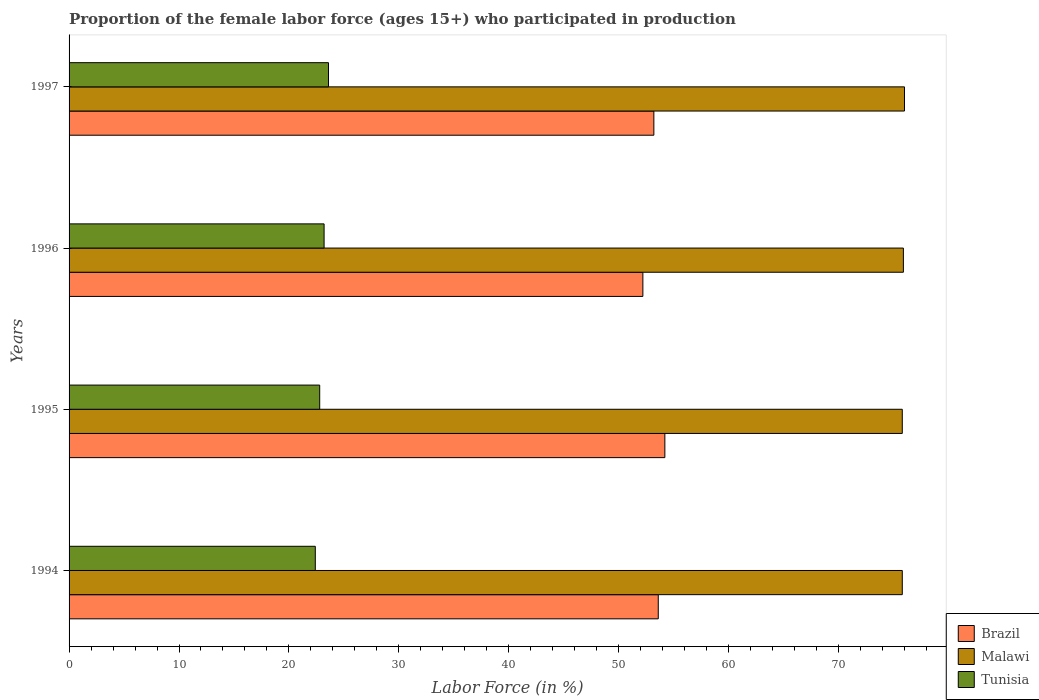How many different coloured bars are there?
Your answer should be compact. 3. How many groups of bars are there?
Provide a succinct answer. 4. Are the number of bars per tick equal to the number of legend labels?
Your response must be concise. Yes. What is the label of the 3rd group of bars from the top?
Your response must be concise. 1995. What is the proportion of the female labor force who participated in production in Brazil in 1997?
Offer a very short reply. 53.2. Across all years, what is the maximum proportion of the female labor force who participated in production in Tunisia?
Ensure brevity in your answer.  23.6. Across all years, what is the minimum proportion of the female labor force who participated in production in Brazil?
Your answer should be very brief. 52.2. In which year was the proportion of the female labor force who participated in production in Tunisia maximum?
Offer a very short reply. 1997. What is the total proportion of the female labor force who participated in production in Tunisia in the graph?
Your answer should be compact. 92. What is the difference between the proportion of the female labor force who participated in production in Tunisia in 1995 and that in 1996?
Ensure brevity in your answer.  -0.4. What is the difference between the proportion of the female labor force who participated in production in Tunisia in 1996 and the proportion of the female labor force who participated in production in Brazil in 1995?
Give a very brief answer. -31. What is the average proportion of the female labor force who participated in production in Malawi per year?
Ensure brevity in your answer.  75.88. In the year 1995, what is the difference between the proportion of the female labor force who participated in production in Brazil and proportion of the female labor force who participated in production in Tunisia?
Offer a very short reply. 31.4. In how many years, is the proportion of the female labor force who participated in production in Brazil greater than 4 %?
Provide a succinct answer. 4. What is the ratio of the proportion of the female labor force who participated in production in Tunisia in 1995 to that in 1996?
Provide a short and direct response. 0.98. Is the difference between the proportion of the female labor force who participated in production in Brazil in 1994 and 1996 greater than the difference between the proportion of the female labor force who participated in production in Tunisia in 1994 and 1996?
Keep it short and to the point. Yes. What is the difference between the highest and the second highest proportion of the female labor force who participated in production in Malawi?
Give a very brief answer. 0.1. What is the difference between the highest and the lowest proportion of the female labor force who participated in production in Malawi?
Keep it short and to the point. 0.2. In how many years, is the proportion of the female labor force who participated in production in Brazil greater than the average proportion of the female labor force who participated in production in Brazil taken over all years?
Provide a succinct answer. 2. What does the 1st bar from the top in 1997 represents?
Your answer should be very brief. Tunisia. What does the 3rd bar from the bottom in 1994 represents?
Your response must be concise. Tunisia. Is it the case that in every year, the sum of the proportion of the female labor force who participated in production in Malawi and proportion of the female labor force who participated in production in Tunisia is greater than the proportion of the female labor force who participated in production in Brazil?
Provide a succinct answer. Yes. How many bars are there?
Keep it short and to the point. 12. What is the difference between two consecutive major ticks on the X-axis?
Make the answer very short. 10. Are the values on the major ticks of X-axis written in scientific E-notation?
Make the answer very short. No. Does the graph contain grids?
Your answer should be compact. No. How many legend labels are there?
Ensure brevity in your answer.  3. How are the legend labels stacked?
Make the answer very short. Vertical. What is the title of the graph?
Offer a terse response. Proportion of the female labor force (ages 15+) who participated in production. What is the label or title of the X-axis?
Provide a succinct answer. Labor Force (in %). What is the label or title of the Y-axis?
Provide a short and direct response. Years. What is the Labor Force (in %) in Brazil in 1994?
Make the answer very short. 53.6. What is the Labor Force (in %) in Malawi in 1994?
Your answer should be compact. 75.8. What is the Labor Force (in %) in Tunisia in 1994?
Make the answer very short. 22.4. What is the Labor Force (in %) in Brazil in 1995?
Ensure brevity in your answer.  54.2. What is the Labor Force (in %) in Malawi in 1995?
Keep it short and to the point. 75.8. What is the Labor Force (in %) of Tunisia in 1995?
Provide a short and direct response. 22.8. What is the Labor Force (in %) of Brazil in 1996?
Give a very brief answer. 52.2. What is the Labor Force (in %) in Malawi in 1996?
Provide a short and direct response. 75.9. What is the Labor Force (in %) of Tunisia in 1996?
Your answer should be compact. 23.2. What is the Labor Force (in %) of Brazil in 1997?
Your answer should be compact. 53.2. What is the Labor Force (in %) in Malawi in 1997?
Provide a short and direct response. 76. What is the Labor Force (in %) of Tunisia in 1997?
Your answer should be very brief. 23.6. Across all years, what is the maximum Labor Force (in %) in Brazil?
Your answer should be compact. 54.2. Across all years, what is the maximum Labor Force (in %) in Tunisia?
Your answer should be very brief. 23.6. Across all years, what is the minimum Labor Force (in %) in Brazil?
Ensure brevity in your answer.  52.2. Across all years, what is the minimum Labor Force (in %) in Malawi?
Keep it short and to the point. 75.8. Across all years, what is the minimum Labor Force (in %) in Tunisia?
Give a very brief answer. 22.4. What is the total Labor Force (in %) of Brazil in the graph?
Keep it short and to the point. 213.2. What is the total Labor Force (in %) in Malawi in the graph?
Make the answer very short. 303.5. What is the total Labor Force (in %) of Tunisia in the graph?
Give a very brief answer. 92. What is the difference between the Labor Force (in %) of Malawi in 1994 and that in 1995?
Your answer should be compact. 0. What is the difference between the Labor Force (in %) of Tunisia in 1994 and that in 1996?
Ensure brevity in your answer.  -0.8. What is the difference between the Labor Force (in %) in Brazil in 1994 and that in 1997?
Offer a terse response. 0.4. What is the difference between the Labor Force (in %) in Tunisia in 1994 and that in 1997?
Make the answer very short. -1.2. What is the difference between the Labor Force (in %) of Tunisia in 1995 and that in 1996?
Offer a terse response. -0.4. What is the difference between the Labor Force (in %) in Brazil in 1995 and that in 1997?
Give a very brief answer. 1. What is the difference between the Labor Force (in %) of Tunisia in 1995 and that in 1997?
Your answer should be very brief. -0.8. What is the difference between the Labor Force (in %) of Tunisia in 1996 and that in 1997?
Provide a succinct answer. -0.4. What is the difference between the Labor Force (in %) in Brazil in 1994 and the Labor Force (in %) in Malawi in 1995?
Ensure brevity in your answer.  -22.2. What is the difference between the Labor Force (in %) in Brazil in 1994 and the Labor Force (in %) in Tunisia in 1995?
Your answer should be very brief. 30.8. What is the difference between the Labor Force (in %) in Brazil in 1994 and the Labor Force (in %) in Malawi in 1996?
Offer a very short reply. -22.3. What is the difference between the Labor Force (in %) of Brazil in 1994 and the Labor Force (in %) of Tunisia in 1996?
Provide a succinct answer. 30.4. What is the difference between the Labor Force (in %) of Malawi in 1994 and the Labor Force (in %) of Tunisia in 1996?
Give a very brief answer. 52.6. What is the difference between the Labor Force (in %) in Brazil in 1994 and the Labor Force (in %) in Malawi in 1997?
Keep it short and to the point. -22.4. What is the difference between the Labor Force (in %) of Malawi in 1994 and the Labor Force (in %) of Tunisia in 1997?
Make the answer very short. 52.2. What is the difference between the Labor Force (in %) of Brazil in 1995 and the Labor Force (in %) of Malawi in 1996?
Provide a succinct answer. -21.7. What is the difference between the Labor Force (in %) in Brazil in 1995 and the Labor Force (in %) in Tunisia in 1996?
Your answer should be very brief. 31. What is the difference between the Labor Force (in %) in Malawi in 1995 and the Labor Force (in %) in Tunisia in 1996?
Provide a succinct answer. 52.6. What is the difference between the Labor Force (in %) in Brazil in 1995 and the Labor Force (in %) in Malawi in 1997?
Offer a very short reply. -21.8. What is the difference between the Labor Force (in %) of Brazil in 1995 and the Labor Force (in %) of Tunisia in 1997?
Ensure brevity in your answer.  30.6. What is the difference between the Labor Force (in %) in Malawi in 1995 and the Labor Force (in %) in Tunisia in 1997?
Your response must be concise. 52.2. What is the difference between the Labor Force (in %) in Brazil in 1996 and the Labor Force (in %) in Malawi in 1997?
Provide a short and direct response. -23.8. What is the difference between the Labor Force (in %) in Brazil in 1996 and the Labor Force (in %) in Tunisia in 1997?
Provide a succinct answer. 28.6. What is the difference between the Labor Force (in %) of Malawi in 1996 and the Labor Force (in %) of Tunisia in 1997?
Your answer should be compact. 52.3. What is the average Labor Force (in %) of Brazil per year?
Ensure brevity in your answer.  53.3. What is the average Labor Force (in %) of Malawi per year?
Keep it short and to the point. 75.88. What is the average Labor Force (in %) in Tunisia per year?
Provide a short and direct response. 23. In the year 1994, what is the difference between the Labor Force (in %) of Brazil and Labor Force (in %) of Malawi?
Your answer should be compact. -22.2. In the year 1994, what is the difference between the Labor Force (in %) in Brazil and Labor Force (in %) in Tunisia?
Make the answer very short. 31.2. In the year 1994, what is the difference between the Labor Force (in %) of Malawi and Labor Force (in %) of Tunisia?
Offer a very short reply. 53.4. In the year 1995, what is the difference between the Labor Force (in %) of Brazil and Labor Force (in %) of Malawi?
Keep it short and to the point. -21.6. In the year 1995, what is the difference between the Labor Force (in %) in Brazil and Labor Force (in %) in Tunisia?
Your answer should be very brief. 31.4. In the year 1996, what is the difference between the Labor Force (in %) of Brazil and Labor Force (in %) of Malawi?
Offer a very short reply. -23.7. In the year 1996, what is the difference between the Labor Force (in %) in Malawi and Labor Force (in %) in Tunisia?
Offer a terse response. 52.7. In the year 1997, what is the difference between the Labor Force (in %) of Brazil and Labor Force (in %) of Malawi?
Your response must be concise. -22.8. In the year 1997, what is the difference between the Labor Force (in %) in Brazil and Labor Force (in %) in Tunisia?
Make the answer very short. 29.6. In the year 1997, what is the difference between the Labor Force (in %) in Malawi and Labor Force (in %) in Tunisia?
Your answer should be compact. 52.4. What is the ratio of the Labor Force (in %) in Brazil in 1994 to that in 1995?
Provide a succinct answer. 0.99. What is the ratio of the Labor Force (in %) of Tunisia in 1994 to that in 1995?
Provide a short and direct response. 0.98. What is the ratio of the Labor Force (in %) of Brazil in 1994 to that in 1996?
Give a very brief answer. 1.03. What is the ratio of the Labor Force (in %) of Tunisia in 1994 to that in 1996?
Your answer should be compact. 0.97. What is the ratio of the Labor Force (in %) of Brazil in 1994 to that in 1997?
Ensure brevity in your answer.  1.01. What is the ratio of the Labor Force (in %) of Malawi in 1994 to that in 1997?
Provide a short and direct response. 1. What is the ratio of the Labor Force (in %) of Tunisia in 1994 to that in 1997?
Offer a terse response. 0.95. What is the ratio of the Labor Force (in %) in Brazil in 1995 to that in 1996?
Your answer should be very brief. 1.04. What is the ratio of the Labor Force (in %) of Tunisia in 1995 to that in 1996?
Keep it short and to the point. 0.98. What is the ratio of the Labor Force (in %) in Brazil in 1995 to that in 1997?
Keep it short and to the point. 1.02. What is the ratio of the Labor Force (in %) of Malawi in 1995 to that in 1997?
Provide a succinct answer. 1. What is the ratio of the Labor Force (in %) of Tunisia in 1995 to that in 1997?
Ensure brevity in your answer.  0.97. What is the ratio of the Labor Force (in %) in Brazil in 1996 to that in 1997?
Provide a succinct answer. 0.98. What is the ratio of the Labor Force (in %) of Malawi in 1996 to that in 1997?
Make the answer very short. 1. What is the ratio of the Labor Force (in %) of Tunisia in 1996 to that in 1997?
Keep it short and to the point. 0.98. What is the difference between the highest and the second highest Labor Force (in %) in Brazil?
Provide a short and direct response. 0.6. What is the difference between the highest and the lowest Labor Force (in %) in Malawi?
Ensure brevity in your answer.  0.2. 